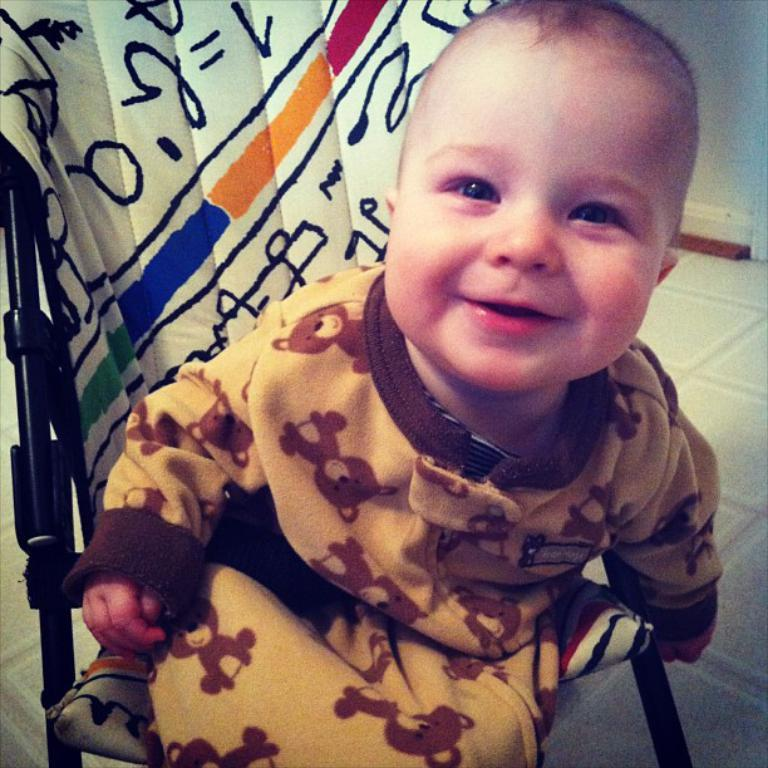What is the main subject of the image? There is a kid in the center of the image. What is the kid doing in the image? The kid is sitting on a chair. What can be seen in the background of the image? There is a wall in the background of the image. What is visible at the bottom of the image? There is a floor visible at the bottom of the image. What type of lettuce is being used as bait in the image? There is no lettuce or bait present in the image; it features a kid sitting on a chair with a wall in the background and a visible floor. 